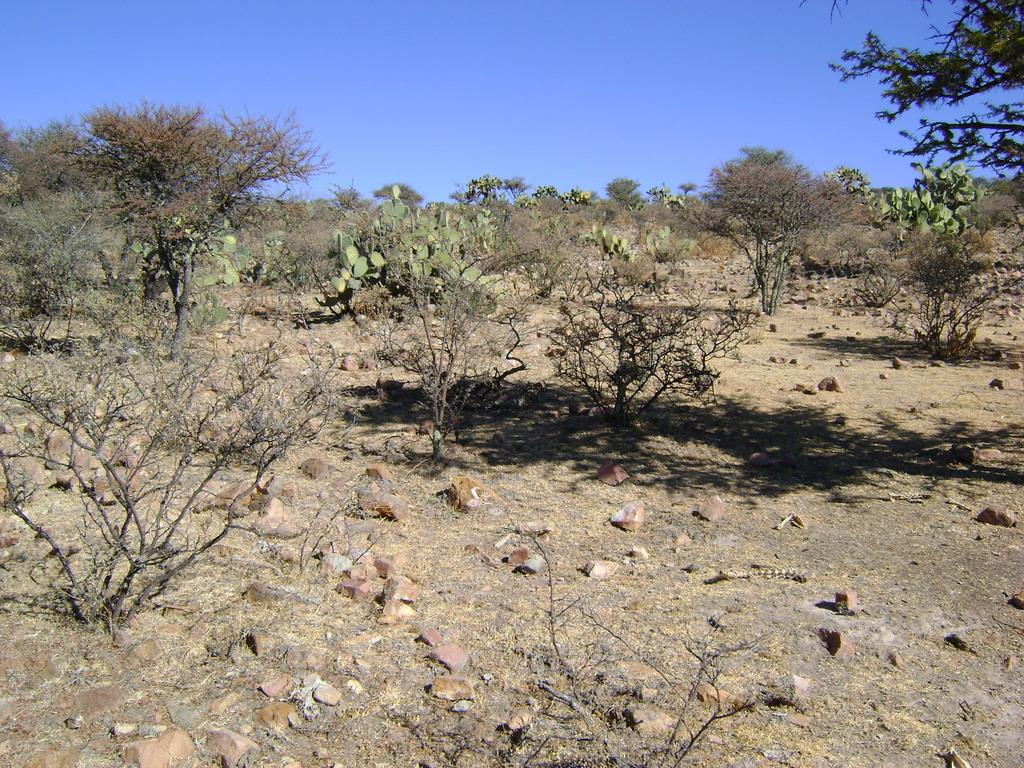What type of surface is visible in the image? There is ground visible in the image. What can be found on the ground in the image? There are rocks on the ground. What type of vegetation is present in the image? There are trees in the image. What colors can be seen on the trees? The trees have brown and green colors. What is visible in the background of the image? The sky is visible in the background of the image. How many fingers can be seen on the trees in the image? There are no fingers present on the trees in the image; trees do not have fingers. 